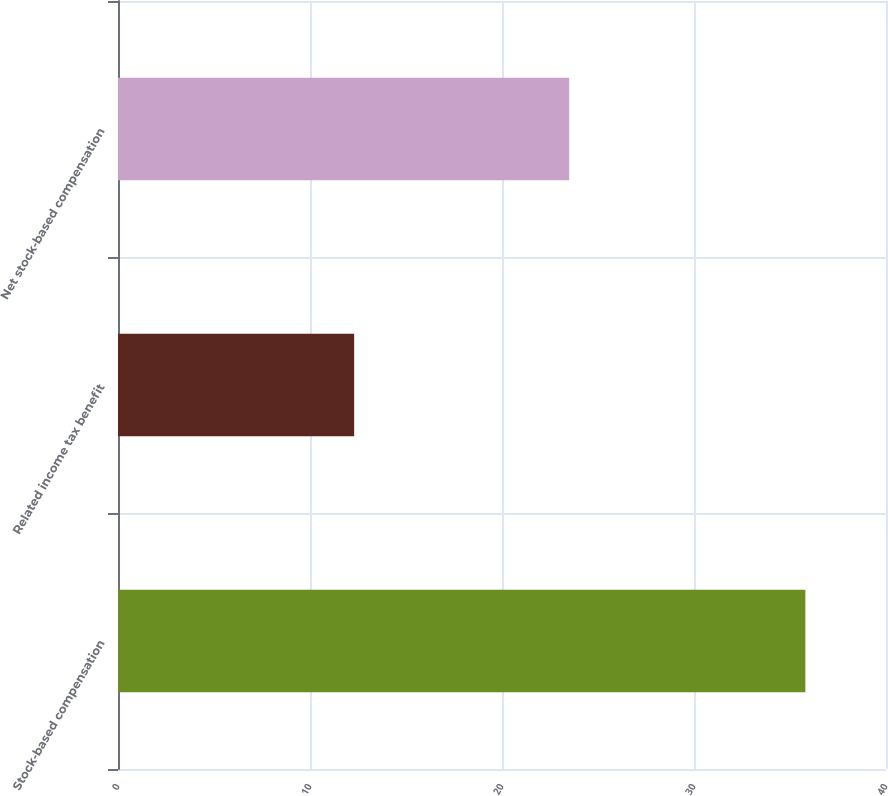Convert chart to OTSL. <chart><loc_0><loc_0><loc_500><loc_500><bar_chart><fcel>Stock-based compensation<fcel>Related income tax benefit<fcel>Net stock-based compensation<nl><fcel>35.8<fcel>12.3<fcel>23.5<nl></chart> 